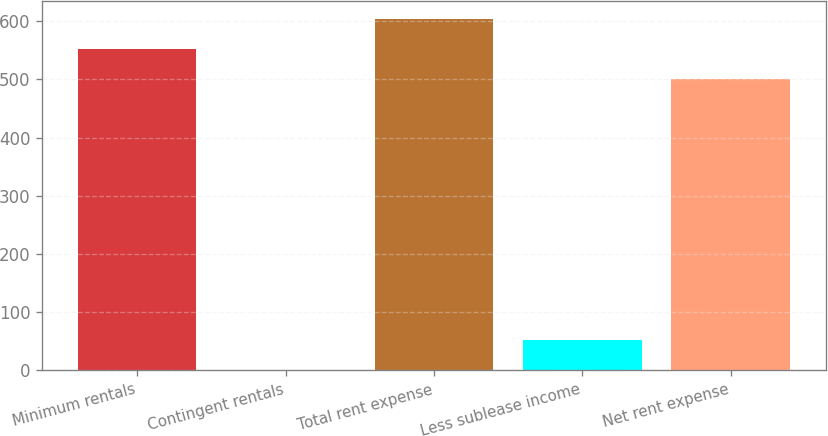Convert chart to OTSL. <chart><loc_0><loc_0><loc_500><loc_500><bar_chart><fcel>Minimum rentals<fcel>Contingent rentals<fcel>Total rent expense<fcel>Less sublease income<fcel>Net rent expense<nl><fcel>552.6<fcel>1<fcel>604.2<fcel>52.6<fcel>501<nl></chart> 